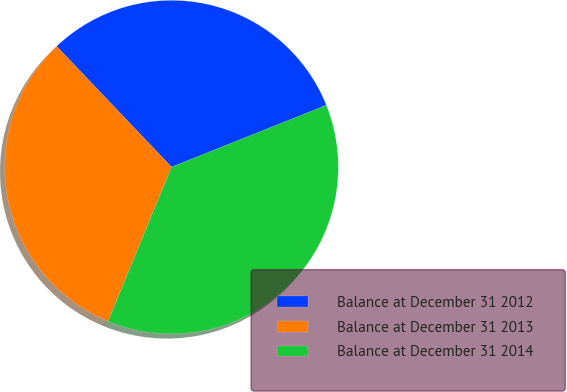Convert chart. <chart><loc_0><loc_0><loc_500><loc_500><pie_chart><fcel>Balance at December 31 2012<fcel>Balance at December 31 2013<fcel>Balance at December 31 2014<nl><fcel>31.06%<fcel>31.68%<fcel>37.27%<nl></chart> 